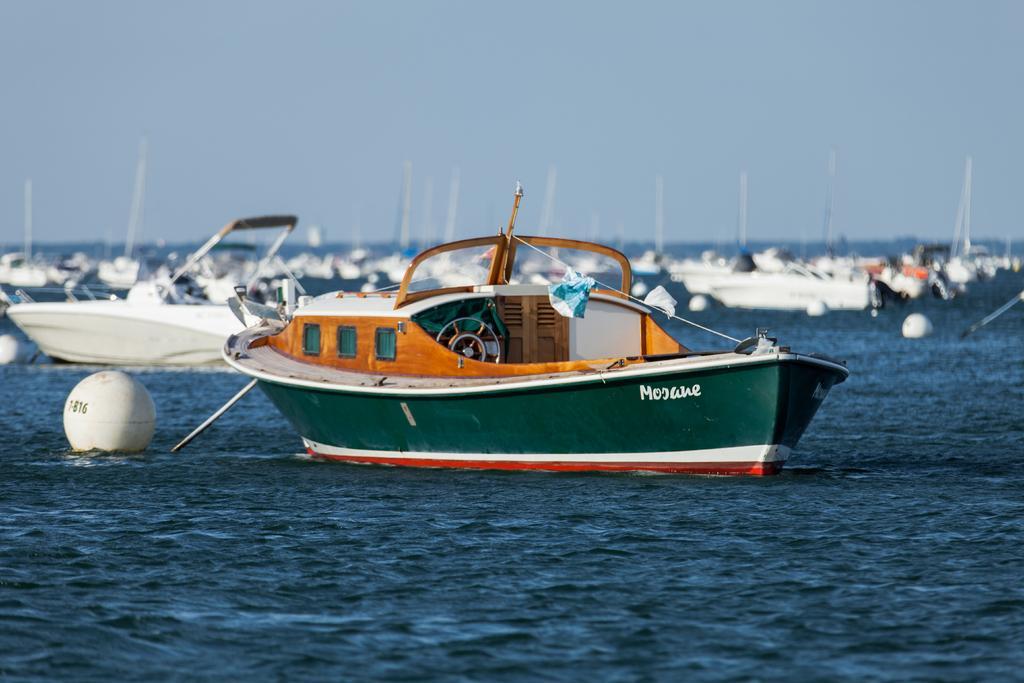Could you give a brief overview of what you see in this image? This picture is clicked outside the city. In the foreground we can see a water body. In the center we can see the boats and some other items in the water body. In the background there is a sky. 